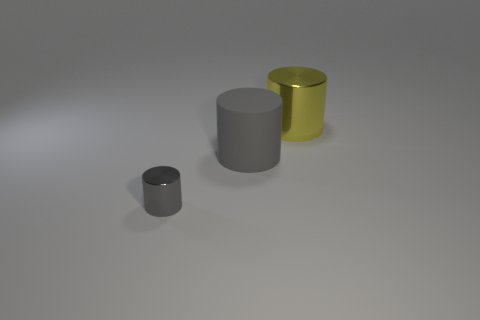Subtract all gray cylinders. How many cylinders are left? 1 Add 2 yellow things. How many objects exist? 5 Subtract all blue cubes. How many gray cylinders are left? 2 Subtract all gray cylinders. How many cylinders are left? 1 Subtract all large gray rubber objects. Subtract all big rubber cylinders. How many objects are left? 1 Add 1 tiny gray objects. How many tiny gray objects are left? 2 Add 1 large yellow shiny cylinders. How many large yellow shiny cylinders exist? 2 Subtract 0 cyan blocks. How many objects are left? 3 Subtract all purple cylinders. Subtract all green balls. How many cylinders are left? 3 